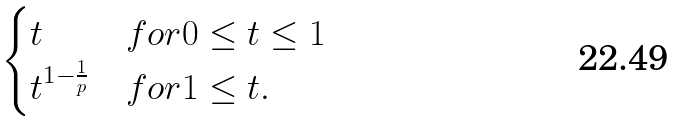<formula> <loc_0><loc_0><loc_500><loc_500>\begin{cases} t & f o r 0 \leq t \leq 1 \\ t ^ { 1 - \frac { 1 } { p } } & f o r 1 \leq t . \end{cases}</formula> 